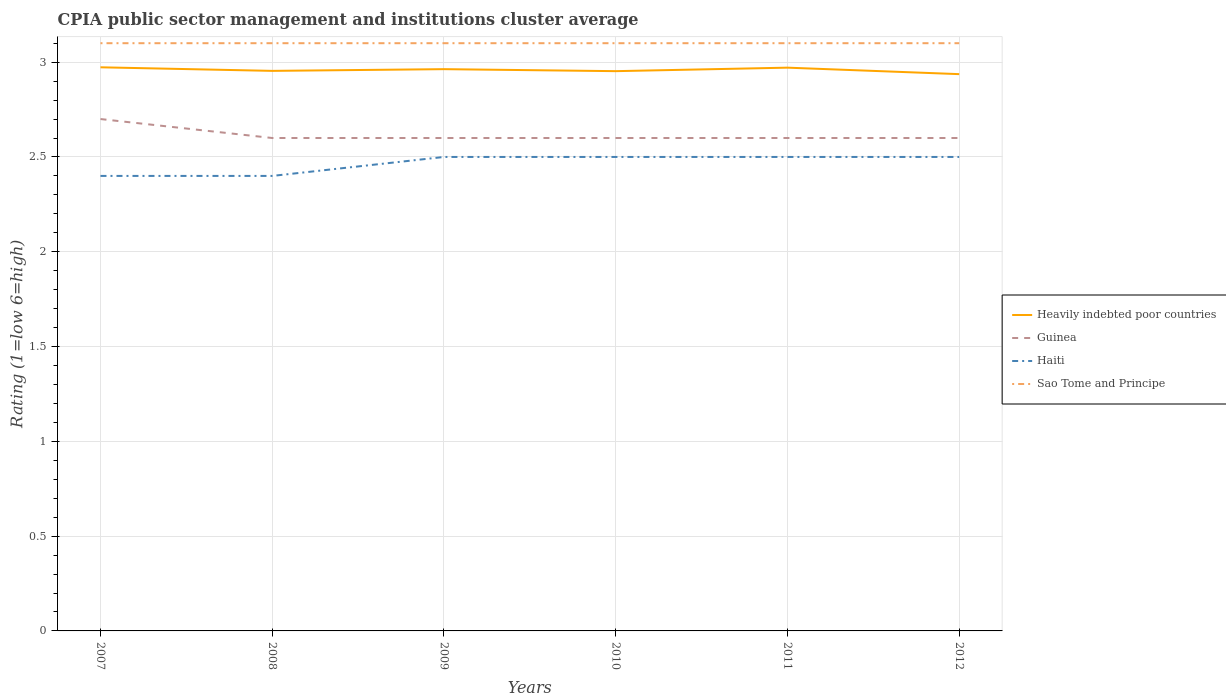Across all years, what is the maximum CPIA rating in Heavily indebted poor countries?
Your answer should be very brief. 2.94. In which year was the CPIA rating in Sao Tome and Principe maximum?
Keep it short and to the point. 2007. What is the total CPIA rating in Haiti in the graph?
Offer a terse response. -0.1. What is the difference between the highest and the second highest CPIA rating in Guinea?
Provide a succinct answer. 0.1. What is the difference between the highest and the lowest CPIA rating in Haiti?
Keep it short and to the point. 4. Is the CPIA rating in Sao Tome and Principe strictly greater than the CPIA rating in Guinea over the years?
Your answer should be compact. No. Are the values on the major ticks of Y-axis written in scientific E-notation?
Ensure brevity in your answer.  No. Where does the legend appear in the graph?
Your response must be concise. Center right. How many legend labels are there?
Make the answer very short. 4. What is the title of the graph?
Your answer should be very brief. CPIA public sector management and institutions cluster average. What is the label or title of the X-axis?
Give a very brief answer. Years. What is the label or title of the Y-axis?
Your answer should be compact. Rating (1=low 6=high). What is the Rating (1=low 6=high) in Heavily indebted poor countries in 2007?
Make the answer very short. 2.97. What is the Rating (1=low 6=high) in Guinea in 2007?
Your answer should be very brief. 2.7. What is the Rating (1=low 6=high) of Haiti in 2007?
Your response must be concise. 2.4. What is the Rating (1=low 6=high) in Sao Tome and Principe in 2007?
Your response must be concise. 3.1. What is the Rating (1=low 6=high) of Heavily indebted poor countries in 2008?
Your answer should be very brief. 2.95. What is the Rating (1=low 6=high) in Haiti in 2008?
Your answer should be very brief. 2.4. What is the Rating (1=low 6=high) of Heavily indebted poor countries in 2009?
Offer a very short reply. 2.96. What is the Rating (1=low 6=high) of Guinea in 2009?
Ensure brevity in your answer.  2.6. What is the Rating (1=low 6=high) of Haiti in 2009?
Your response must be concise. 2.5. What is the Rating (1=low 6=high) of Sao Tome and Principe in 2009?
Offer a very short reply. 3.1. What is the Rating (1=low 6=high) of Heavily indebted poor countries in 2010?
Make the answer very short. 2.95. What is the Rating (1=low 6=high) in Guinea in 2010?
Offer a very short reply. 2.6. What is the Rating (1=low 6=high) of Heavily indebted poor countries in 2011?
Give a very brief answer. 2.97. What is the Rating (1=low 6=high) of Guinea in 2011?
Your answer should be compact. 2.6. What is the Rating (1=low 6=high) in Sao Tome and Principe in 2011?
Make the answer very short. 3.1. What is the Rating (1=low 6=high) of Heavily indebted poor countries in 2012?
Provide a short and direct response. 2.94. What is the Rating (1=low 6=high) of Guinea in 2012?
Offer a very short reply. 2.6. What is the Rating (1=low 6=high) of Haiti in 2012?
Give a very brief answer. 2.5. What is the Rating (1=low 6=high) in Sao Tome and Principe in 2012?
Offer a terse response. 3.1. Across all years, what is the maximum Rating (1=low 6=high) of Heavily indebted poor countries?
Keep it short and to the point. 2.97. Across all years, what is the maximum Rating (1=low 6=high) in Guinea?
Provide a succinct answer. 2.7. Across all years, what is the minimum Rating (1=low 6=high) of Heavily indebted poor countries?
Give a very brief answer. 2.94. Across all years, what is the minimum Rating (1=low 6=high) of Sao Tome and Principe?
Offer a very short reply. 3.1. What is the total Rating (1=low 6=high) of Heavily indebted poor countries in the graph?
Provide a short and direct response. 17.75. What is the total Rating (1=low 6=high) in Haiti in the graph?
Your response must be concise. 14.8. What is the difference between the Rating (1=low 6=high) of Heavily indebted poor countries in 2007 and that in 2008?
Your answer should be compact. 0.02. What is the difference between the Rating (1=low 6=high) in Guinea in 2007 and that in 2008?
Offer a very short reply. 0.1. What is the difference between the Rating (1=low 6=high) in Haiti in 2007 and that in 2008?
Offer a very short reply. 0. What is the difference between the Rating (1=low 6=high) in Heavily indebted poor countries in 2007 and that in 2009?
Offer a very short reply. 0.01. What is the difference between the Rating (1=low 6=high) in Sao Tome and Principe in 2007 and that in 2009?
Make the answer very short. 0. What is the difference between the Rating (1=low 6=high) in Heavily indebted poor countries in 2007 and that in 2010?
Your answer should be very brief. 0.02. What is the difference between the Rating (1=low 6=high) in Haiti in 2007 and that in 2010?
Your answer should be very brief. -0.1. What is the difference between the Rating (1=low 6=high) in Sao Tome and Principe in 2007 and that in 2010?
Make the answer very short. 0. What is the difference between the Rating (1=low 6=high) of Heavily indebted poor countries in 2007 and that in 2011?
Give a very brief answer. 0. What is the difference between the Rating (1=low 6=high) of Guinea in 2007 and that in 2011?
Give a very brief answer. 0.1. What is the difference between the Rating (1=low 6=high) in Sao Tome and Principe in 2007 and that in 2011?
Provide a short and direct response. 0. What is the difference between the Rating (1=low 6=high) of Heavily indebted poor countries in 2007 and that in 2012?
Give a very brief answer. 0.04. What is the difference between the Rating (1=low 6=high) in Haiti in 2007 and that in 2012?
Provide a succinct answer. -0.1. What is the difference between the Rating (1=low 6=high) of Sao Tome and Principe in 2007 and that in 2012?
Provide a short and direct response. 0. What is the difference between the Rating (1=low 6=high) in Heavily indebted poor countries in 2008 and that in 2009?
Keep it short and to the point. -0.01. What is the difference between the Rating (1=low 6=high) of Guinea in 2008 and that in 2009?
Your response must be concise. 0. What is the difference between the Rating (1=low 6=high) in Haiti in 2008 and that in 2009?
Ensure brevity in your answer.  -0.1. What is the difference between the Rating (1=low 6=high) in Sao Tome and Principe in 2008 and that in 2009?
Give a very brief answer. 0. What is the difference between the Rating (1=low 6=high) of Heavily indebted poor countries in 2008 and that in 2010?
Offer a terse response. 0. What is the difference between the Rating (1=low 6=high) in Sao Tome and Principe in 2008 and that in 2010?
Your answer should be very brief. 0. What is the difference between the Rating (1=low 6=high) in Heavily indebted poor countries in 2008 and that in 2011?
Your answer should be very brief. -0.02. What is the difference between the Rating (1=low 6=high) of Haiti in 2008 and that in 2011?
Ensure brevity in your answer.  -0.1. What is the difference between the Rating (1=low 6=high) in Heavily indebted poor countries in 2008 and that in 2012?
Offer a very short reply. 0.02. What is the difference between the Rating (1=low 6=high) of Guinea in 2008 and that in 2012?
Ensure brevity in your answer.  0. What is the difference between the Rating (1=low 6=high) of Haiti in 2008 and that in 2012?
Your response must be concise. -0.1. What is the difference between the Rating (1=low 6=high) of Sao Tome and Principe in 2008 and that in 2012?
Offer a terse response. 0. What is the difference between the Rating (1=low 6=high) of Heavily indebted poor countries in 2009 and that in 2010?
Keep it short and to the point. 0.01. What is the difference between the Rating (1=low 6=high) in Guinea in 2009 and that in 2010?
Offer a terse response. 0. What is the difference between the Rating (1=low 6=high) of Haiti in 2009 and that in 2010?
Offer a very short reply. 0. What is the difference between the Rating (1=low 6=high) of Sao Tome and Principe in 2009 and that in 2010?
Provide a short and direct response. 0. What is the difference between the Rating (1=low 6=high) in Heavily indebted poor countries in 2009 and that in 2011?
Your response must be concise. -0.01. What is the difference between the Rating (1=low 6=high) in Heavily indebted poor countries in 2009 and that in 2012?
Make the answer very short. 0.03. What is the difference between the Rating (1=low 6=high) in Haiti in 2009 and that in 2012?
Offer a terse response. 0. What is the difference between the Rating (1=low 6=high) in Sao Tome and Principe in 2009 and that in 2012?
Your response must be concise. 0. What is the difference between the Rating (1=low 6=high) of Heavily indebted poor countries in 2010 and that in 2011?
Offer a terse response. -0.02. What is the difference between the Rating (1=low 6=high) of Heavily indebted poor countries in 2010 and that in 2012?
Keep it short and to the point. 0.02. What is the difference between the Rating (1=low 6=high) in Haiti in 2010 and that in 2012?
Offer a terse response. 0. What is the difference between the Rating (1=low 6=high) in Sao Tome and Principe in 2010 and that in 2012?
Offer a very short reply. 0. What is the difference between the Rating (1=low 6=high) of Heavily indebted poor countries in 2011 and that in 2012?
Provide a short and direct response. 0.03. What is the difference between the Rating (1=low 6=high) of Guinea in 2011 and that in 2012?
Provide a succinct answer. 0. What is the difference between the Rating (1=low 6=high) of Haiti in 2011 and that in 2012?
Ensure brevity in your answer.  0. What is the difference between the Rating (1=low 6=high) of Sao Tome and Principe in 2011 and that in 2012?
Keep it short and to the point. 0. What is the difference between the Rating (1=low 6=high) in Heavily indebted poor countries in 2007 and the Rating (1=low 6=high) in Guinea in 2008?
Offer a very short reply. 0.37. What is the difference between the Rating (1=low 6=high) of Heavily indebted poor countries in 2007 and the Rating (1=low 6=high) of Haiti in 2008?
Offer a terse response. 0.57. What is the difference between the Rating (1=low 6=high) of Heavily indebted poor countries in 2007 and the Rating (1=low 6=high) of Sao Tome and Principe in 2008?
Your answer should be very brief. -0.13. What is the difference between the Rating (1=low 6=high) of Guinea in 2007 and the Rating (1=low 6=high) of Haiti in 2008?
Your response must be concise. 0.3. What is the difference between the Rating (1=low 6=high) of Heavily indebted poor countries in 2007 and the Rating (1=low 6=high) of Guinea in 2009?
Ensure brevity in your answer.  0.37. What is the difference between the Rating (1=low 6=high) of Heavily indebted poor countries in 2007 and the Rating (1=low 6=high) of Haiti in 2009?
Your response must be concise. 0.47. What is the difference between the Rating (1=low 6=high) of Heavily indebted poor countries in 2007 and the Rating (1=low 6=high) of Sao Tome and Principe in 2009?
Your answer should be very brief. -0.13. What is the difference between the Rating (1=low 6=high) of Heavily indebted poor countries in 2007 and the Rating (1=low 6=high) of Guinea in 2010?
Provide a short and direct response. 0.37. What is the difference between the Rating (1=low 6=high) of Heavily indebted poor countries in 2007 and the Rating (1=low 6=high) of Haiti in 2010?
Make the answer very short. 0.47. What is the difference between the Rating (1=low 6=high) of Heavily indebted poor countries in 2007 and the Rating (1=low 6=high) of Sao Tome and Principe in 2010?
Provide a succinct answer. -0.13. What is the difference between the Rating (1=low 6=high) of Guinea in 2007 and the Rating (1=low 6=high) of Haiti in 2010?
Keep it short and to the point. 0.2. What is the difference between the Rating (1=low 6=high) of Guinea in 2007 and the Rating (1=low 6=high) of Sao Tome and Principe in 2010?
Your response must be concise. -0.4. What is the difference between the Rating (1=low 6=high) in Heavily indebted poor countries in 2007 and the Rating (1=low 6=high) in Guinea in 2011?
Offer a terse response. 0.37. What is the difference between the Rating (1=low 6=high) in Heavily indebted poor countries in 2007 and the Rating (1=low 6=high) in Haiti in 2011?
Make the answer very short. 0.47. What is the difference between the Rating (1=low 6=high) in Heavily indebted poor countries in 2007 and the Rating (1=low 6=high) in Sao Tome and Principe in 2011?
Provide a succinct answer. -0.13. What is the difference between the Rating (1=low 6=high) of Guinea in 2007 and the Rating (1=low 6=high) of Haiti in 2011?
Provide a succinct answer. 0.2. What is the difference between the Rating (1=low 6=high) in Heavily indebted poor countries in 2007 and the Rating (1=low 6=high) in Guinea in 2012?
Keep it short and to the point. 0.37. What is the difference between the Rating (1=low 6=high) of Heavily indebted poor countries in 2007 and the Rating (1=low 6=high) of Haiti in 2012?
Ensure brevity in your answer.  0.47. What is the difference between the Rating (1=low 6=high) of Heavily indebted poor countries in 2007 and the Rating (1=low 6=high) of Sao Tome and Principe in 2012?
Your response must be concise. -0.13. What is the difference between the Rating (1=low 6=high) in Guinea in 2007 and the Rating (1=low 6=high) in Sao Tome and Principe in 2012?
Provide a short and direct response. -0.4. What is the difference between the Rating (1=low 6=high) in Haiti in 2007 and the Rating (1=low 6=high) in Sao Tome and Principe in 2012?
Your response must be concise. -0.7. What is the difference between the Rating (1=low 6=high) in Heavily indebted poor countries in 2008 and the Rating (1=low 6=high) in Guinea in 2009?
Provide a succinct answer. 0.35. What is the difference between the Rating (1=low 6=high) in Heavily indebted poor countries in 2008 and the Rating (1=low 6=high) in Haiti in 2009?
Your answer should be compact. 0.45. What is the difference between the Rating (1=low 6=high) in Heavily indebted poor countries in 2008 and the Rating (1=low 6=high) in Sao Tome and Principe in 2009?
Your answer should be compact. -0.15. What is the difference between the Rating (1=low 6=high) in Heavily indebted poor countries in 2008 and the Rating (1=low 6=high) in Guinea in 2010?
Offer a very short reply. 0.35. What is the difference between the Rating (1=low 6=high) of Heavily indebted poor countries in 2008 and the Rating (1=low 6=high) of Haiti in 2010?
Make the answer very short. 0.45. What is the difference between the Rating (1=low 6=high) in Heavily indebted poor countries in 2008 and the Rating (1=low 6=high) in Sao Tome and Principe in 2010?
Your answer should be very brief. -0.15. What is the difference between the Rating (1=low 6=high) in Guinea in 2008 and the Rating (1=low 6=high) in Haiti in 2010?
Offer a very short reply. 0.1. What is the difference between the Rating (1=low 6=high) in Guinea in 2008 and the Rating (1=low 6=high) in Sao Tome and Principe in 2010?
Provide a short and direct response. -0.5. What is the difference between the Rating (1=low 6=high) in Heavily indebted poor countries in 2008 and the Rating (1=low 6=high) in Guinea in 2011?
Give a very brief answer. 0.35. What is the difference between the Rating (1=low 6=high) of Heavily indebted poor countries in 2008 and the Rating (1=low 6=high) of Haiti in 2011?
Your answer should be compact. 0.45. What is the difference between the Rating (1=low 6=high) of Heavily indebted poor countries in 2008 and the Rating (1=low 6=high) of Sao Tome and Principe in 2011?
Make the answer very short. -0.15. What is the difference between the Rating (1=low 6=high) of Haiti in 2008 and the Rating (1=low 6=high) of Sao Tome and Principe in 2011?
Your response must be concise. -0.7. What is the difference between the Rating (1=low 6=high) of Heavily indebted poor countries in 2008 and the Rating (1=low 6=high) of Guinea in 2012?
Offer a terse response. 0.35. What is the difference between the Rating (1=low 6=high) in Heavily indebted poor countries in 2008 and the Rating (1=low 6=high) in Haiti in 2012?
Ensure brevity in your answer.  0.45. What is the difference between the Rating (1=low 6=high) of Heavily indebted poor countries in 2008 and the Rating (1=low 6=high) of Sao Tome and Principe in 2012?
Provide a short and direct response. -0.15. What is the difference between the Rating (1=low 6=high) of Guinea in 2008 and the Rating (1=low 6=high) of Haiti in 2012?
Give a very brief answer. 0.1. What is the difference between the Rating (1=low 6=high) in Heavily indebted poor countries in 2009 and the Rating (1=low 6=high) in Guinea in 2010?
Give a very brief answer. 0.36. What is the difference between the Rating (1=low 6=high) of Heavily indebted poor countries in 2009 and the Rating (1=low 6=high) of Haiti in 2010?
Your answer should be compact. 0.46. What is the difference between the Rating (1=low 6=high) in Heavily indebted poor countries in 2009 and the Rating (1=low 6=high) in Sao Tome and Principe in 2010?
Offer a terse response. -0.14. What is the difference between the Rating (1=low 6=high) of Guinea in 2009 and the Rating (1=low 6=high) of Haiti in 2010?
Offer a very short reply. 0.1. What is the difference between the Rating (1=low 6=high) of Haiti in 2009 and the Rating (1=low 6=high) of Sao Tome and Principe in 2010?
Make the answer very short. -0.6. What is the difference between the Rating (1=low 6=high) of Heavily indebted poor countries in 2009 and the Rating (1=low 6=high) of Guinea in 2011?
Provide a short and direct response. 0.36. What is the difference between the Rating (1=low 6=high) in Heavily indebted poor countries in 2009 and the Rating (1=low 6=high) in Haiti in 2011?
Your answer should be very brief. 0.46. What is the difference between the Rating (1=low 6=high) of Heavily indebted poor countries in 2009 and the Rating (1=low 6=high) of Sao Tome and Principe in 2011?
Ensure brevity in your answer.  -0.14. What is the difference between the Rating (1=low 6=high) in Guinea in 2009 and the Rating (1=low 6=high) in Haiti in 2011?
Make the answer very short. 0.1. What is the difference between the Rating (1=low 6=high) of Guinea in 2009 and the Rating (1=low 6=high) of Sao Tome and Principe in 2011?
Your answer should be very brief. -0.5. What is the difference between the Rating (1=low 6=high) of Heavily indebted poor countries in 2009 and the Rating (1=low 6=high) of Guinea in 2012?
Make the answer very short. 0.36. What is the difference between the Rating (1=low 6=high) in Heavily indebted poor countries in 2009 and the Rating (1=low 6=high) in Haiti in 2012?
Offer a terse response. 0.46. What is the difference between the Rating (1=low 6=high) of Heavily indebted poor countries in 2009 and the Rating (1=low 6=high) of Sao Tome and Principe in 2012?
Offer a terse response. -0.14. What is the difference between the Rating (1=low 6=high) of Guinea in 2009 and the Rating (1=low 6=high) of Haiti in 2012?
Your response must be concise. 0.1. What is the difference between the Rating (1=low 6=high) in Haiti in 2009 and the Rating (1=low 6=high) in Sao Tome and Principe in 2012?
Offer a terse response. -0.6. What is the difference between the Rating (1=low 6=high) of Heavily indebted poor countries in 2010 and the Rating (1=low 6=high) of Guinea in 2011?
Your answer should be very brief. 0.35. What is the difference between the Rating (1=low 6=high) of Heavily indebted poor countries in 2010 and the Rating (1=low 6=high) of Haiti in 2011?
Ensure brevity in your answer.  0.45. What is the difference between the Rating (1=low 6=high) in Heavily indebted poor countries in 2010 and the Rating (1=low 6=high) in Sao Tome and Principe in 2011?
Keep it short and to the point. -0.15. What is the difference between the Rating (1=low 6=high) of Guinea in 2010 and the Rating (1=low 6=high) of Sao Tome and Principe in 2011?
Provide a succinct answer. -0.5. What is the difference between the Rating (1=low 6=high) in Heavily indebted poor countries in 2010 and the Rating (1=low 6=high) in Guinea in 2012?
Give a very brief answer. 0.35. What is the difference between the Rating (1=low 6=high) of Heavily indebted poor countries in 2010 and the Rating (1=low 6=high) of Haiti in 2012?
Make the answer very short. 0.45. What is the difference between the Rating (1=low 6=high) of Heavily indebted poor countries in 2010 and the Rating (1=low 6=high) of Sao Tome and Principe in 2012?
Provide a short and direct response. -0.15. What is the difference between the Rating (1=low 6=high) of Guinea in 2010 and the Rating (1=low 6=high) of Haiti in 2012?
Offer a terse response. 0.1. What is the difference between the Rating (1=low 6=high) of Guinea in 2010 and the Rating (1=low 6=high) of Sao Tome and Principe in 2012?
Keep it short and to the point. -0.5. What is the difference between the Rating (1=low 6=high) in Heavily indebted poor countries in 2011 and the Rating (1=low 6=high) in Guinea in 2012?
Give a very brief answer. 0.37. What is the difference between the Rating (1=low 6=high) of Heavily indebted poor countries in 2011 and the Rating (1=low 6=high) of Haiti in 2012?
Make the answer very short. 0.47. What is the difference between the Rating (1=low 6=high) in Heavily indebted poor countries in 2011 and the Rating (1=low 6=high) in Sao Tome and Principe in 2012?
Make the answer very short. -0.13. What is the difference between the Rating (1=low 6=high) of Guinea in 2011 and the Rating (1=low 6=high) of Haiti in 2012?
Offer a very short reply. 0.1. What is the difference between the Rating (1=low 6=high) in Guinea in 2011 and the Rating (1=low 6=high) in Sao Tome and Principe in 2012?
Your response must be concise. -0.5. What is the difference between the Rating (1=low 6=high) in Haiti in 2011 and the Rating (1=low 6=high) in Sao Tome and Principe in 2012?
Make the answer very short. -0.6. What is the average Rating (1=low 6=high) in Heavily indebted poor countries per year?
Your answer should be very brief. 2.96. What is the average Rating (1=low 6=high) in Guinea per year?
Make the answer very short. 2.62. What is the average Rating (1=low 6=high) in Haiti per year?
Your response must be concise. 2.47. What is the average Rating (1=low 6=high) of Sao Tome and Principe per year?
Make the answer very short. 3.1. In the year 2007, what is the difference between the Rating (1=low 6=high) in Heavily indebted poor countries and Rating (1=low 6=high) in Guinea?
Provide a short and direct response. 0.27. In the year 2007, what is the difference between the Rating (1=low 6=high) in Heavily indebted poor countries and Rating (1=low 6=high) in Haiti?
Your response must be concise. 0.57. In the year 2007, what is the difference between the Rating (1=low 6=high) in Heavily indebted poor countries and Rating (1=low 6=high) in Sao Tome and Principe?
Keep it short and to the point. -0.13. In the year 2008, what is the difference between the Rating (1=low 6=high) of Heavily indebted poor countries and Rating (1=low 6=high) of Guinea?
Your answer should be compact. 0.35. In the year 2008, what is the difference between the Rating (1=low 6=high) of Heavily indebted poor countries and Rating (1=low 6=high) of Haiti?
Make the answer very short. 0.55. In the year 2008, what is the difference between the Rating (1=low 6=high) in Heavily indebted poor countries and Rating (1=low 6=high) in Sao Tome and Principe?
Provide a short and direct response. -0.15. In the year 2008, what is the difference between the Rating (1=low 6=high) of Guinea and Rating (1=low 6=high) of Haiti?
Keep it short and to the point. 0.2. In the year 2008, what is the difference between the Rating (1=low 6=high) in Haiti and Rating (1=low 6=high) in Sao Tome and Principe?
Your answer should be compact. -0.7. In the year 2009, what is the difference between the Rating (1=low 6=high) of Heavily indebted poor countries and Rating (1=low 6=high) of Guinea?
Ensure brevity in your answer.  0.36. In the year 2009, what is the difference between the Rating (1=low 6=high) of Heavily indebted poor countries and Rating (1=low 6=high) of Haiti?
Your answer should be very brief. 0.46. In the year 2009, what is the difference between the Rating (1=low 6=high) in Heavily indebted poor countries and Rating (1=low 6=high) in Sao Tome and Principe?
Provide a short and direct response. -0.14. In the year 2009, what is the difference between the Rating (1=low 6=high) in Guinea and Rating (1=low 6=high) in Haiti?
Offer a terse response. 0.1. In the year 2009, what is the difference between the Rating (1=low 6=high) of Guinea and Rating (1=low 6=high) of Sao Tome and Principe?
Make the answer very short. -0.5. In the year 2010, what is the difference between the Rating (1=low 6=high) of Heavily indebted poor countries and Rating (1=low 6=high) of Guinea?
Your answer should be very brief. 0.35. In the year 2010, what is the difference between the Rating (1=low 6=high) in Heavily indebted poor countries and Rating (1=low 6=high) in Haiti?
Give a very brief answer. 0.45. In the year 2010, what is the difference between the Rating (1=low 6=high) in Heavily indebted poor countries and Rating (1=low 6=high) in Sao Tome and Principe?
Give a very brief answer. -0.15. In the year 2010, what is the difference between the Rating (1=low 6=high) of Guinea and Rating (1=low 6=high) of Haiti?
Give a very brief answer. 0.1. In the year 2010, what is the difference between the Rating (1=low 6=high) of Haiti and Rating (1=low 6=high) of Sao Tome and Principe?
Offer a terse response. -0.6. In the year 2011, what is the difference between the Rating (1=low 6=high) in Heavily indebted poor countries and Rating (1=low 6=high) in Guinea?
Provide a short and direct response. 0.37. In the year 2011, what is the difference between the Rating (1=low 6=high) in Heavily indebted poor countries and Rating (1=low 6=high) in Haiti?
Your answer should be very brief. 0.47. In the year 2011, what is the difference between the Rating (1=low 6=high) in Heavily indebted poor countries and Rating (1=low 6=high) in Sao Tome and Principe?
Provide a succinct answer. -0.13. In the year 2011, what is the difference between the Rating (1=low 6=high) of Guinea and Rating (1=low 6=high) of Sao Tome and Principe?
Provide a succinct answer. -0.5. In the year 2011, what is the difference between the Rating (1=low 6=high) of Haiti and Rating (1=low 6=high) of Sao Tome and Principe?
Your response must be concise. -0.6. In the year 2012, what is the difference between the Rating (1=low 6=high) in Heavily indebted poor countries and Rating (1=low 6=high) in Guinea?
Ensure brevity in your answer.  0.34. In the year 2012, what is the difference between the Rating (1=low 6=high) of Heavily indebted poor countries and Rating (1=low 6=high) of Haiti?
Keep it short and to the point. 0.44. In the year 2012, what is the difference between the Rating (1=low 6=high) of Heavily indebted poor countries and Rating (1=low 6=high) of Sao Tome and Principe?
Your response must be concise. -0.16. What is the ratio of the Rating (1=low 6=high) of Heavily indebted poor countries in 2007 to that in 2008?
Ensure brevity in your answer.  1.01. What is the ratio of the Rating (1=low 6=high) in Guinea in 2007 to that in 2008?
Provide a short and direct response. 1.04. What is the ratio of the Rating (1=low 6=high) in Haiti in 2007 to that in 2008?
Offer a very short reply. 1. What is the ratio of the Rating (1=low 6=high) of Sao Tome and Principe in 2007 to that in 2008?
Give a very brief answer. 1. What is the ratio of the Rating (1=low 6=high) of Guinea in 2007 to that in 2009?
Offer a very short reply. 1.04. What is the ratio of the Rating (1=low 6=high) in Sao Tome and Principe in 2007 to that in 2009?
Provide a short and direct response. 1. What is the ratio of the Rating (1=low 6=high) in Heavily indebted poor countries in 2007 to that in 2010?
Your response must be concise. 1.01. What is the ratio of the Rating (1=low 6=high) of Sao Tome and Principe in 2007 to that in 2010?
Make the answer very short. 1. What is the ratio of the Rating (1=low 6=high) of Guinea in 2007 to that in 2011?
Offer a very short reply. 1.04. What is the ratio of the Rating (1=low 6=high) in Sao Tome and Principe in 2007 to that in 2011?
Your answer should be very brief. 1. What is the ratio of the Rating (1=low 6=high) of Heavily indebted poor countries in 2007 to that in 2012?
Offer a very short reply. 1.01. What is the ratio of the Rating (1=low 6=high) of Heavily indebted poor countries in 2008 to that in 2009?
Your answer should be very brief. 1. What is the ratio of the Rating (1=low 6=high) in Sao Tome and Principe in 2008 to that in 2009?
Offer a terse response. 1. What is the ratio of the Rating (1=low 6=high) in Heavily indebted poor countries in 2008 to that in 2010?
Your answer should be compact. 1. What is the ratio of the Rating (1=low 6=high) in Guinea in 2008 to that in 2010?
Ensure brevity in your answer.  1. What is the ratio of the Rating (1=low 6=high) in Sao Tome and Principe in 2008 to that in 2011?
Offer a terse response. 1. What is the ratio of the Rating (1=low 6=high) in Heavily indebted poor countries in 2008 to that in 2012?
Make the answer very short. 1.01. What is the ratio of the Rating (1=low 6=high) of Guinea in 2008 to that in 2012?
Provide a short and direct response. 1. What is the ratio of the Rating (1=low 6=high) in Guinea in 2009 to that in 2010?
Your answer should be compact. 1. What is the ratio of the Rating (1=low 6=high) in Heavily indebted poor countries in 2009 to that in 2011?
Make the answer very short. 1. What is the ratio of the Rating (1=low 6=high) in Haiti in 2009 to that in 2012?
Keep it short and to the point. 1. What is the ratio of the Rating (1=low 6=high) in Guinea in 2010 to that in 2011?
Make the answer very short. 1. What is the ratio of the Rating (1=low 6=high) of Heavily indebted poor countries in 2010 to that in 2012?
Your answer should be compact. 1.01. What is the ratio of the Rating (1=low 6=high) in Sao Tome and Principe in 2010 to that in 2012?
Give a very brief answer. 1. What is the ratio of the Rating (1=low 6=high) of Heavily indebted poor countries in 2011 to that in 2012?
Ensure brevity in your answer.  1.01. What is the ratio of the Rating (1=low 6=high) in Sao Tome and Principe in 2011 to that in 2012?
Provide a short and direct response. 1. What is the difference between the highest and the second highest Rating (1=low 6=high) in Heavily indebted poor countries?
Offer a very short reply. 0. What is the difference between the highest and the lowest Rating (1=low 6=high) of Heavily indebted poor countries?
Ensure brevity in your answer.  0.04. What is the difference between the highest and the lowest Rating (1=low 6=high) of Guinea?
Offer a terse response. 0.1. What is the difference between the highest and the lowest Rating (1=low 6=high) in Sao Tome and Principe?
Ensure brevity in your answer.  0. 